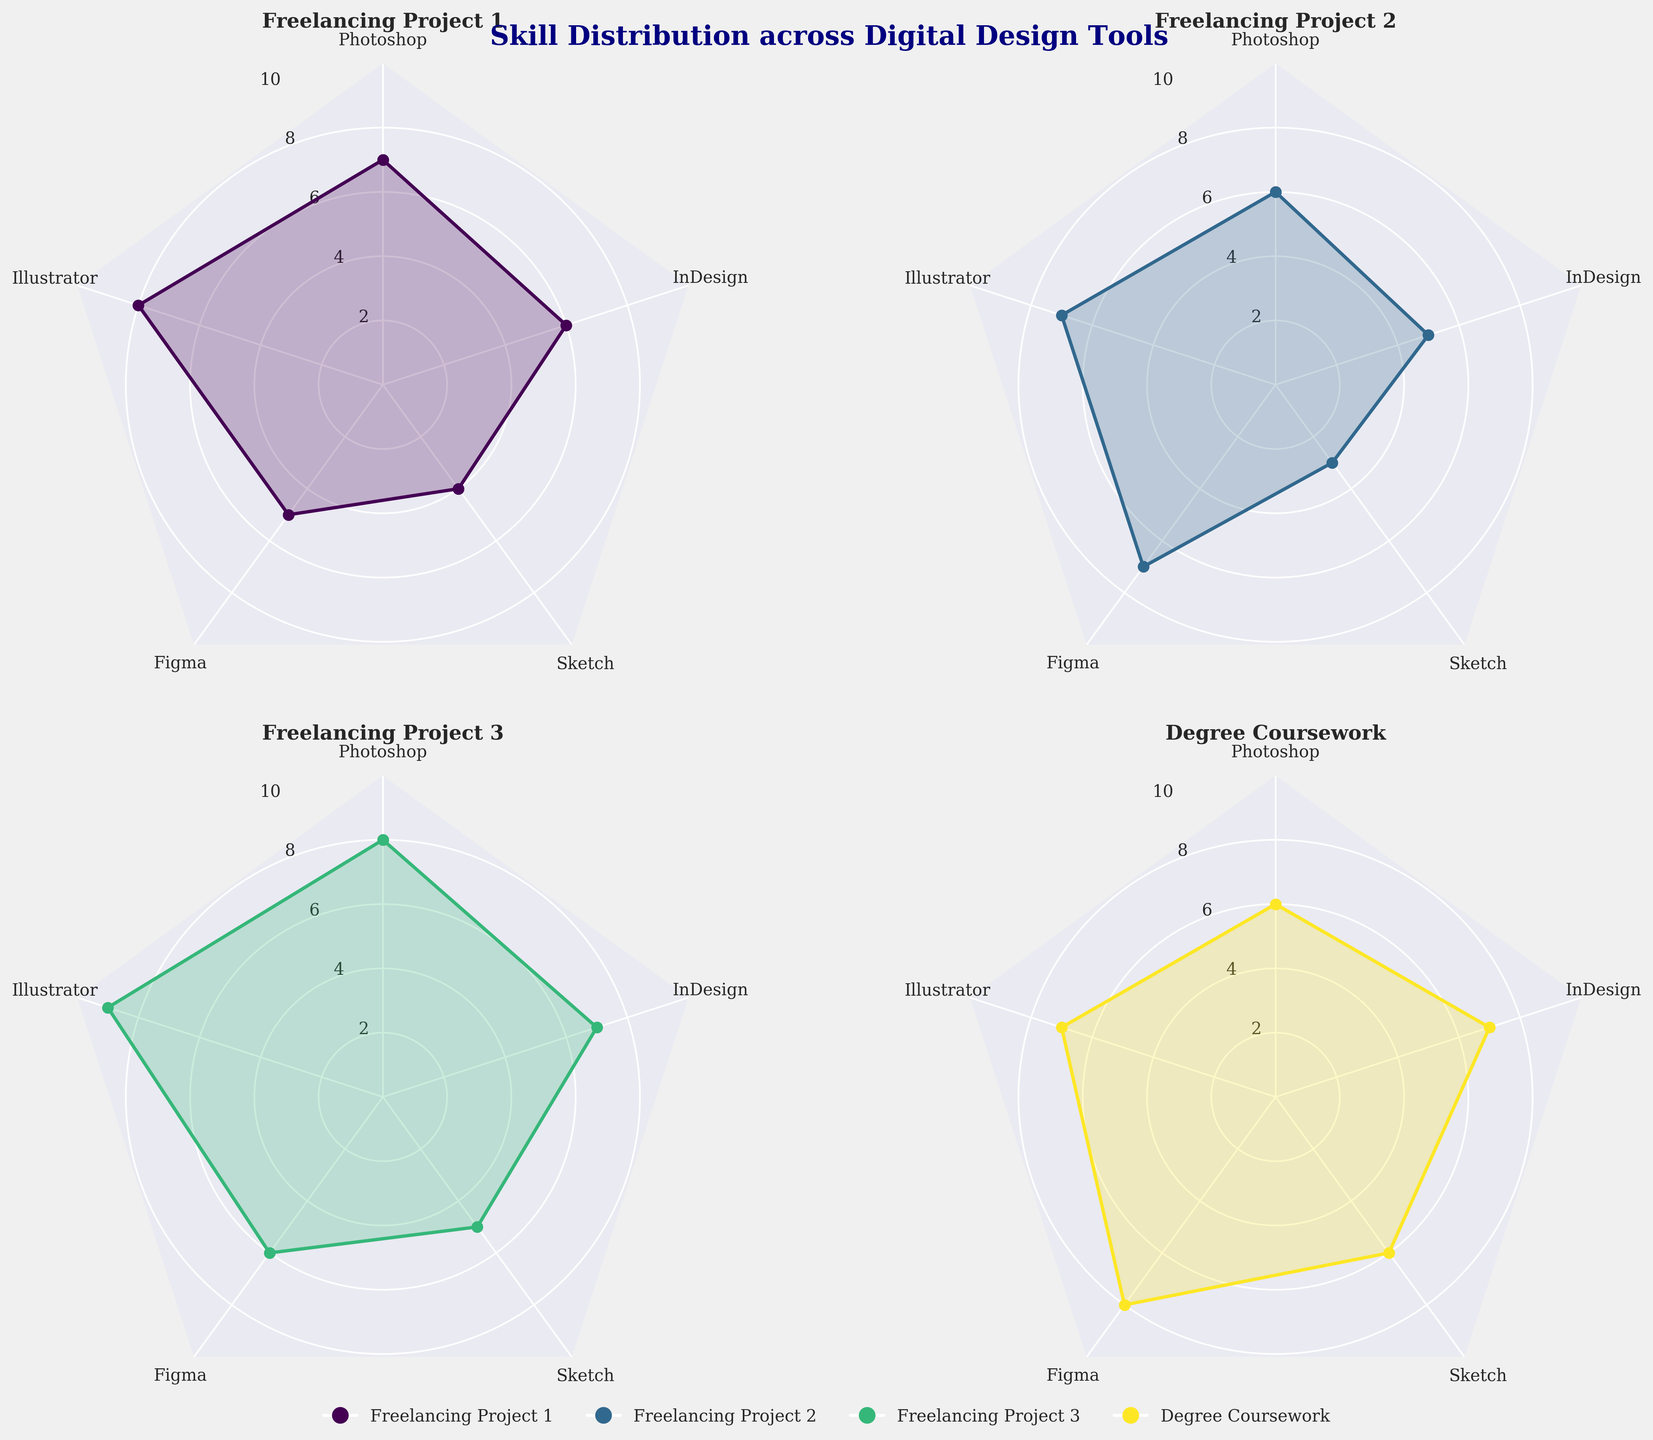What is the highest proficiency level in Illustrator across all jobs? In each subplot, observe the proficiency data points for Illustrator. Freelancing Project 3 has the highest level at 9.
Answer: 9 Which job has the lowest proficiency in Sketch? Look at the Sketch value points in each subplot. Freelancing Project 2 has the lowest proficiency at 3.
Answer: Freelancing Project 2 In which tool do you have the highest proficiency for your Degree Coursework? In the Degree Coursework subplot, find the tool with the highest value point. Figma has the highest proficiency at 8.
Answer: Figma Compare the proficiency in Photoshop and Figma for Freelancing Project 1. Which one is higher? Check the values in the Freelancing Project 1 subplot. The proficiency values are 7 for Photoshop and 5 for Figma; thus, Photoshop is higher.
Answer: Photoshop What is the average proficiency in InDesign across all jobs? Sum the InDesign proficiencies for all jobs (6, 5, 7, 7) and divide by the number of jobs (4). The calculation is (6+5+7+7)/4 = 6.25.
Answer: 6.25 Among all the jobs, which job shows the most balanced proficiency distribution across all tools? Examine the radar charts to see which job has the most consistent values across all tools. The Degree Coursework seems to have the most balanced proficiency distribution with values close to each other.
Answer: Degree Coursework Which job shows the highest variance in proficiency levels? Look at the range of values in each subplot. Freelancing Project 2 ranges from 3 to 7, giving the highest variance.
Answer: Freelancing Project 2 For Freelancing Project 3, calculate the difference between the highest and lowest proficiency levels. Identify the highest proficiency (Illustrator at 9) and lowest proficiency (Sketch at 5) in the subplot for Freelancing Project 3. The difference is 9 - 5 = 4.
Answer: 4 Are there any tools where the proficiency is the same across all jobs? Check each tool's proficiency values across subplots. No tool has the same proficiency across all jobs.
Answer: No Across Freelancing Project 2 and Degree Coursework, which tool has a greater difference in proficiency? Compare each tool's proficiency differences between Freelancing Project 2 and Degree Coursework (Photoshop: 0, Illustrator: 0, Figma: 1, Sketch: 3, InDesign: 2). Sketch has the greatest difference of 3.
Answer: Sketch 